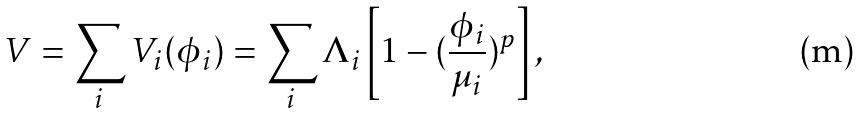<formula> <loc_0><loc_0><loc_500><loc_500>V = \sum _ { i } V _ { i } ( \phi _ { i } ) = \sum _ { i } \Lambda _ { i } \left [ 1 - ( \frac { \phi _ { i } } { \mu _ { i } } ) ^ { p } \right ] ,</formula> 